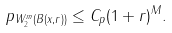<formula> <loc_0><loc_0><loc_500><loc_500>\| p \| _ { W _ { 2 } ^ { m } ( B ( x , r ) ) } \leq C _ { p } ( 1 + r ) ^ { M } .</formula> 